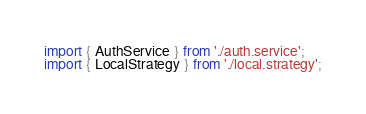<code> <loc_0><loc_0><loc_500><loc_500><_TypeScript_>import { AuthService } from './auth.service';
import { LocalStrategy } from './local.strategy';</code> 